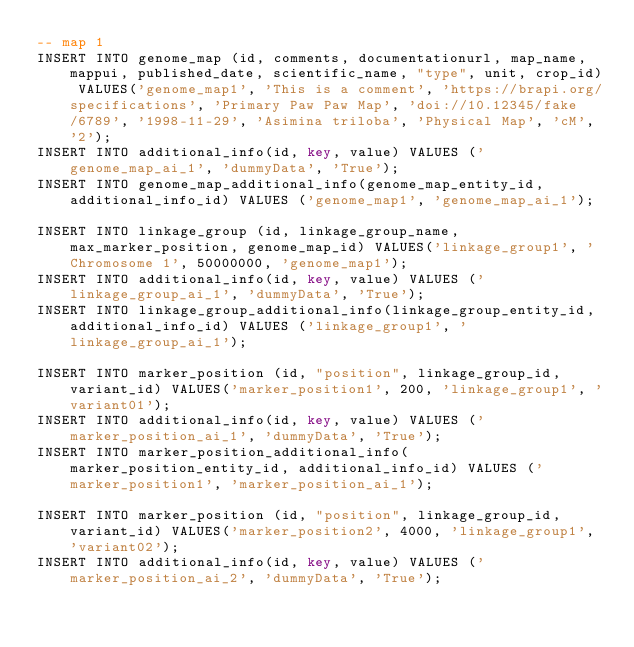Convert code to text. <code><loc_0><loc_0><loc_500><loc_500><_SQL_>-- map 1
INSERT INTO genome_map (id, comments, documentationurl, map_name, mappui, published_date, scientific_name, "type", unit, crop_id) VALUES('genome_map1', 'This is a comment', 'https://brapi.org/specifications', 'Primary Paw Paw Map', 'doi://10.12345/fake/6789', '1998-11-29', 'Asimina triloba', 'Physical Map', 'cM', '2');
INSERT INTO additional_info(id, key, value) VALUES ('genome_map_ai_1', 'dummyData', 'True');
INSERT INTO genome_map_additional_info(genome_map_entity_id, additional_info_id) VALUES ('genome_map1', 'genome_map_ai_1');

INSERT INTO linkage_group (id, linkage_group_name, max_marker_position, genome_map_id) VALUES('linkage_group1', 'Chromosome 1', 50000000, 'genome_map1');
INSERT INTO additional_info(id, key, value) VALUES ('linkage_group_ai_1', 'dummyData', 'True');
INSERT INTO linkage_group_additional_info(linkage_group_entity_id, additional_info_id) VALUES ('linkage_group1', 'linkage_group_ai_1');

INSERT INTO marker_position (id, "position", linkage_group_id, variant_id) VALUES('marker_position1', 200, 'linkage_group1', 'variant01');
INSERT INTO additional_info(id, key, value) VALUES ('marker_position_ai_1', 'dummyData', 'True');
INSERT INTO marker_position_additional_info(marker_position_entity_id, additional_info_id) VALUES ('marker_position1', 'marker_position_ai_1');

INSERT INTO marker_position (id, "position", linkage_group_id, variant_id) VALUES('marker_position2', 4000, 'linkage_group1', 'variant02');
INSERT INTO additional_info(id, key, value) VALUES ('marker_position_ai_2', 'dummyData', 'True');</code> 